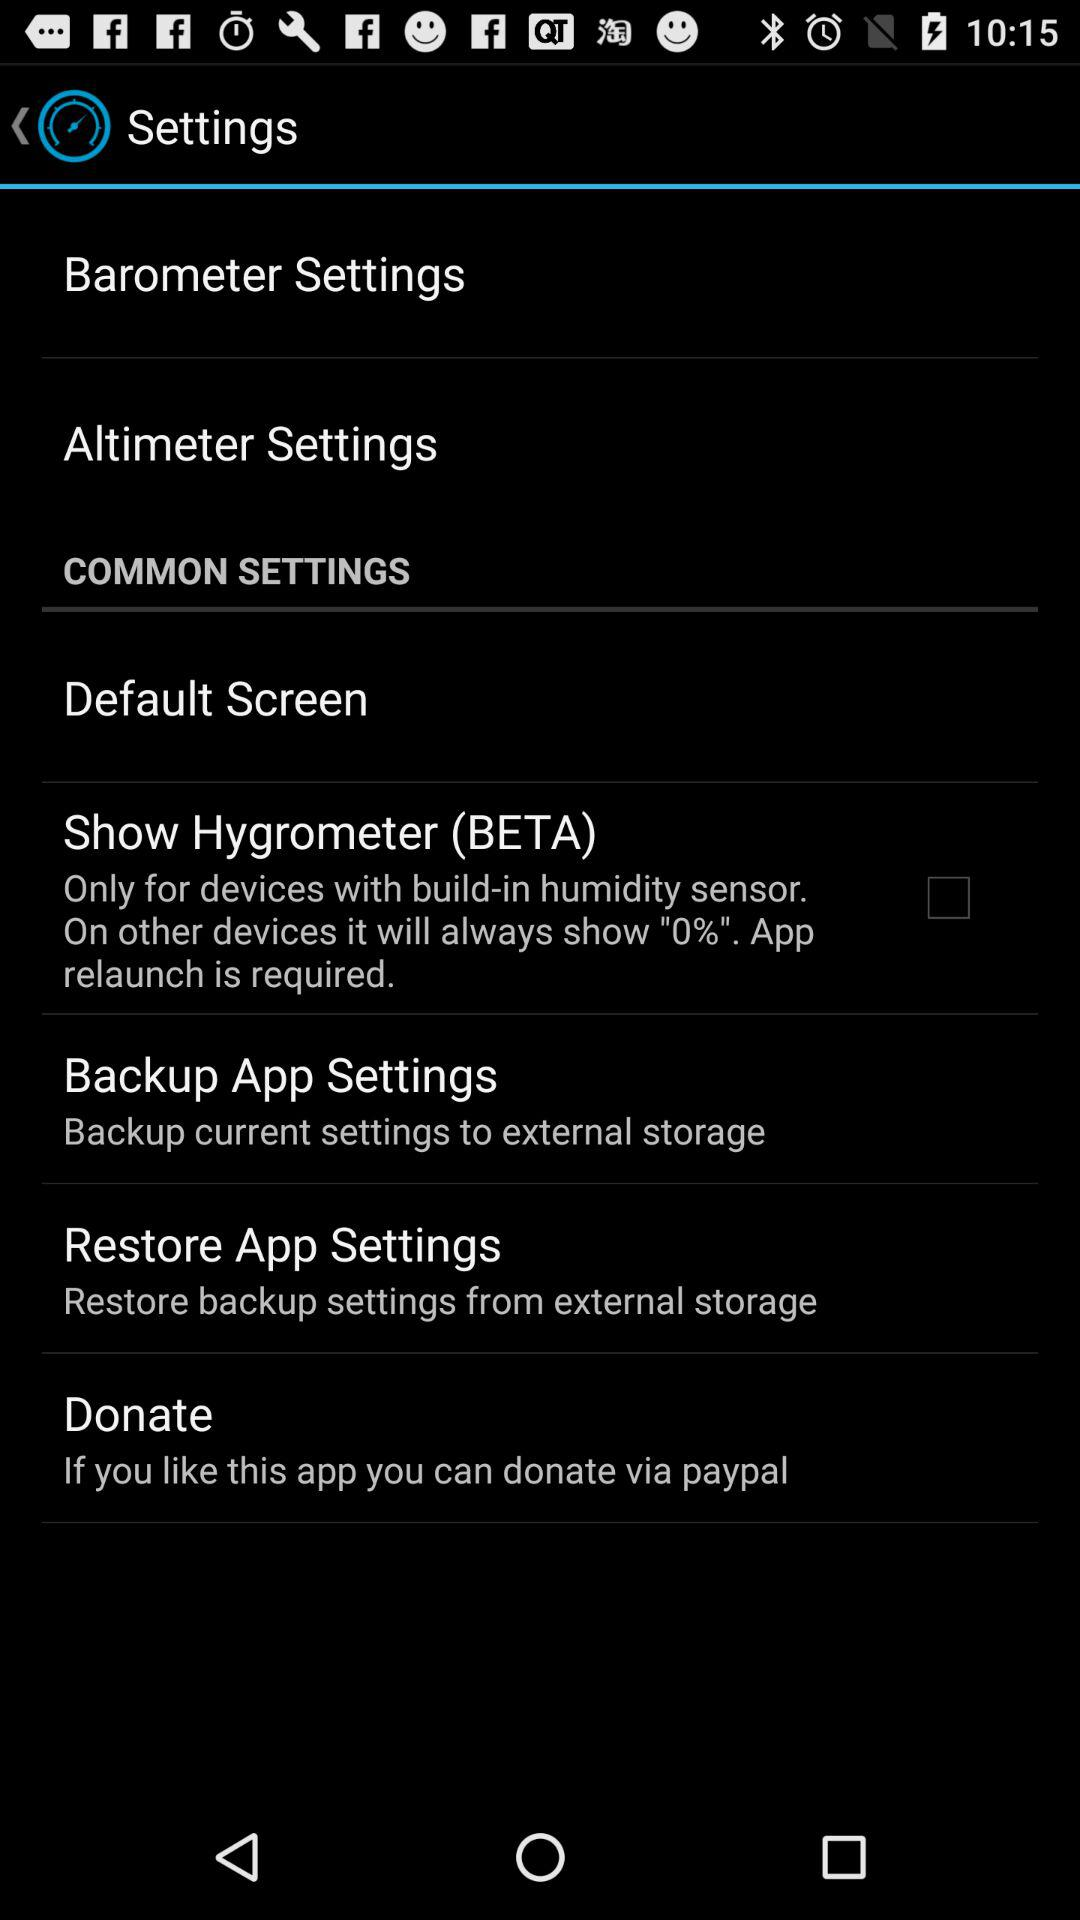Is "Barometer Settings" checked or unchecked?
When the provided information is insufficient, respond with <no answer>. <no answer> 